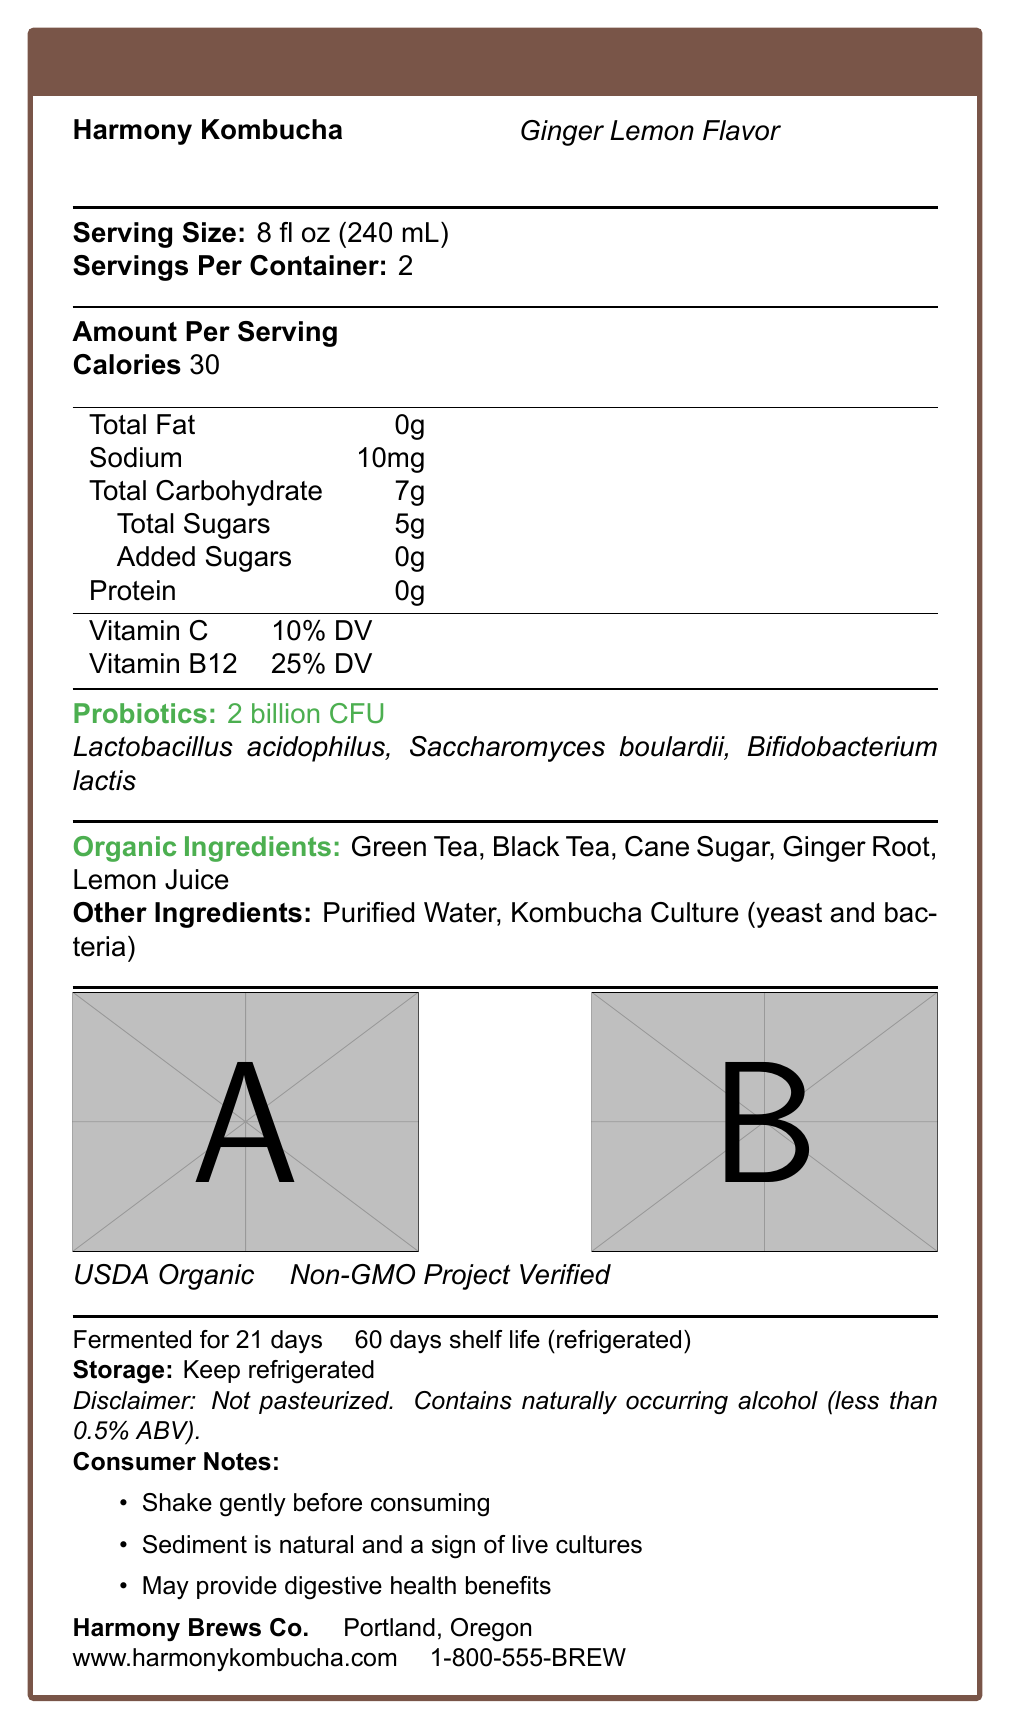what is the serving size of Harmony Kombucha? The serving size is clearly stated as "8 fl oz (240 mL)".
Answer: 8 fl oz (240 mL) how many calories are there per serving? The document lists "Calories 30" under the "Amount Per Serving" section.
Answer: 30 what is the total sugar content per serving? Under the "Total Carbohydrate" section, it specifies "Total Sugars 5g".
Answer: 5g Name one of the probiotic strains found in Harmony Kombucha. The probiotics listed under the "Probiotics" section include Lactobacillus acidophilus, Saccharomyces boulardii, Bifidobacterium lactis.
Answer: Lactobacillus acidophilus What are the main types of organic tea used in Harmony Kombucha? The document specifies Organic Green Tea and Organic Black Tea under the "Organic Ingredients" section.
Answer: Organic Green Tea and Organic Black Tea What is the shelf life of Harmony Kombucha? The shelf life is mentioned as "60 days refrigerated" in the document.
Answer: 60 days refrigerated What are the storage instructions for Harmony Kombucha? Under the "Storage" section, it states "Keep refrigerated".
Answer: Keep refrigerated Does Harmony Kombucha contain any added sugars? The document specifies "Added Sugars 0g", indicating no added sugars.
Answer: No How many servings are in one container of Harmony Kombucha? A. 1 B. 2 C. 4 D. 6 The document states "Servings Per Container: 2".
Answer: B. 2 Which certification does Harmony Kombucha have? A. USDA Organic B. Fair Trade C. Gluten-Free D. Vegan The certifications listed are "USDA Organic" and "Non-GMO Project Verified".
Answer: A. USDA Organic Probiotics in Harmony Kombucha may support which health benefit? A. Immune health B. Digestive health C. Bone health D. Eye health The consumer notes mention "May provide digestive health benefits".
Answer: B. Digestive health Is Harmony Kombucha pasteurized? The disclaimer states "Not pasteurized".
Answer: No Describe the main nutrition and health-related information provided in the document. The document covers nutrition facts per serving, specially mentioning probiotics and organic ingredients. It notes specific health certifications, storage instructions, and consumer advice on handling and health benefits.
Answer: Harmony Kombucha is a fermented drink with probiotics and organic ingredients. It is low in calories, with specific vitamins and probiotic strains noted. It is certified USDA Organic and Non-GMO Project Verified. It has a shelf life of 60 days refrigerated and should be stored in the fridge. It also includes consumer notes about gentle shaking, sediment, and potential digestive health benefits. How many grams of protein does Harmony Kombucha contain per serving? The document lists "Protein 0g" under the "Amount Per Serving" section.
Answer: 0g What flavor is Harmony Kombucha? The document indicates the flavor as "Ginger Lemon".
Answer: Ginger Lemon How much sodium is in one serving of Harmony Kombucha? The sodium content is mentioned as "Sodium 10mg" under the "Amount Per Serving" section.
Answer: 10mg What type of tea is NOT listed as an ingredient in Harmony Kombucha? A. Organic Black Tea B. Organic Green Tea C. Organic White Tea The ingredients list mentions Organic Green Tea and Organic Black Tea but not Organic White Tea.
Answer: C. Organic White Tea What is the fermentation time for Harmony Kombucha? The document states "Fermented for 21 days".
Answer: 21 days Who is the manufacturer of Harmony Kombucha? The document lists the manufacturer as "Harmony Brews Co." from Portland, Oregon.
Answer: Harmony Brews Co. Why should sediment in Harmony Kombucha not be a concern? The document's consumer notes indicate that sediment is natural and a sign of live cultures.
Answer: It is a sign of live cultures. How much naturally occurring alcohol does Harmony Kombucha contain? The disclaimer notes "Contains naturally occurring alcohol (less than 0.5% ABV)".
Answer: Less than 0.5% ABV What is the customer service phone number for Harmony Brews Co.? The customer service contact is listed as "1-800-555-BREW".
Answer: 1-800-555-BREW Is Organic Lemon Juice an ingredient in Harmony Kombucha? Organic Lemon Juice is listed among the Organic Ingredients.
Answer: Yes Can you use the information on the document to determine the price of Harmony Kombucha? The document does not contain any pricing information.
Answer: Not enough information How should Harmony Kombucha be consumed before drinking? The consumer notes advise to "Shake gently before consuming".
Answer: Shake gently 